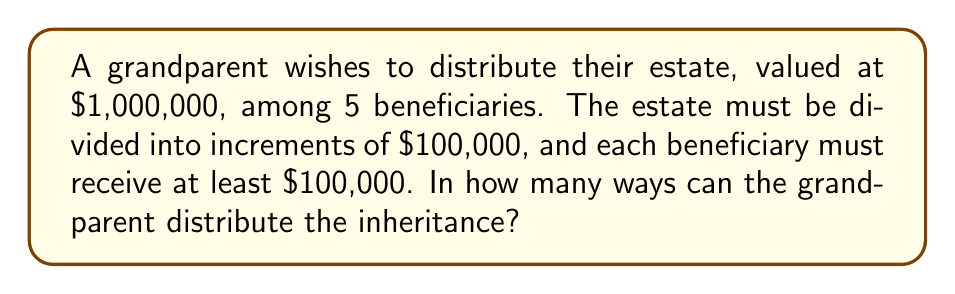Show me your answer to this math problem. Let's approach this step-by-step:

1) First, we need to recognize that this is a stars and bars problem. We are distributing 10 units ($100,000 each) among 5 beneficiaries.

2) However, each beneficiary must receive at least one unit. So, we can first give each beneficiary one unit, and then distribute the remaining units.

3) After giving each beneficiary one unit, we have:
   $1,000,000 - (5 \times 100,000) = 500,000$ left to distribute

4) This means we now have 5 units ($500,000 / 100,000 = 5$) to distribute among 5 beneficiaries, with no restrictions.

5) The formula for stars and bars is:
   $$\binom{n+k-1}{k-1}$$
   where $n$ is the number of identical objects (stars) and $k$ is the number of groups (bars).

6) In our case, $n = 5$ (remaining units) and $k = 5$ (beneficiaries).

7) Plugging into the formula:
   $$\binom{5+5-1}{5-1} = \binom{9}{4}$$

8) Calculate this combination:
   $$\binom{9}{4} = \frac{9!}{4!(9-4)!} = \frac{9!}{4!5!} = 126$$

Therefore, there are 126 ways to distribute the inheritance.
Answer: 126 